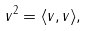Convert formula to latex. <formula><loc_0><loc_0><loc_500><loc_500>\| v \| ^ { 2 } = \langle v , v \rangle ,</formula> 